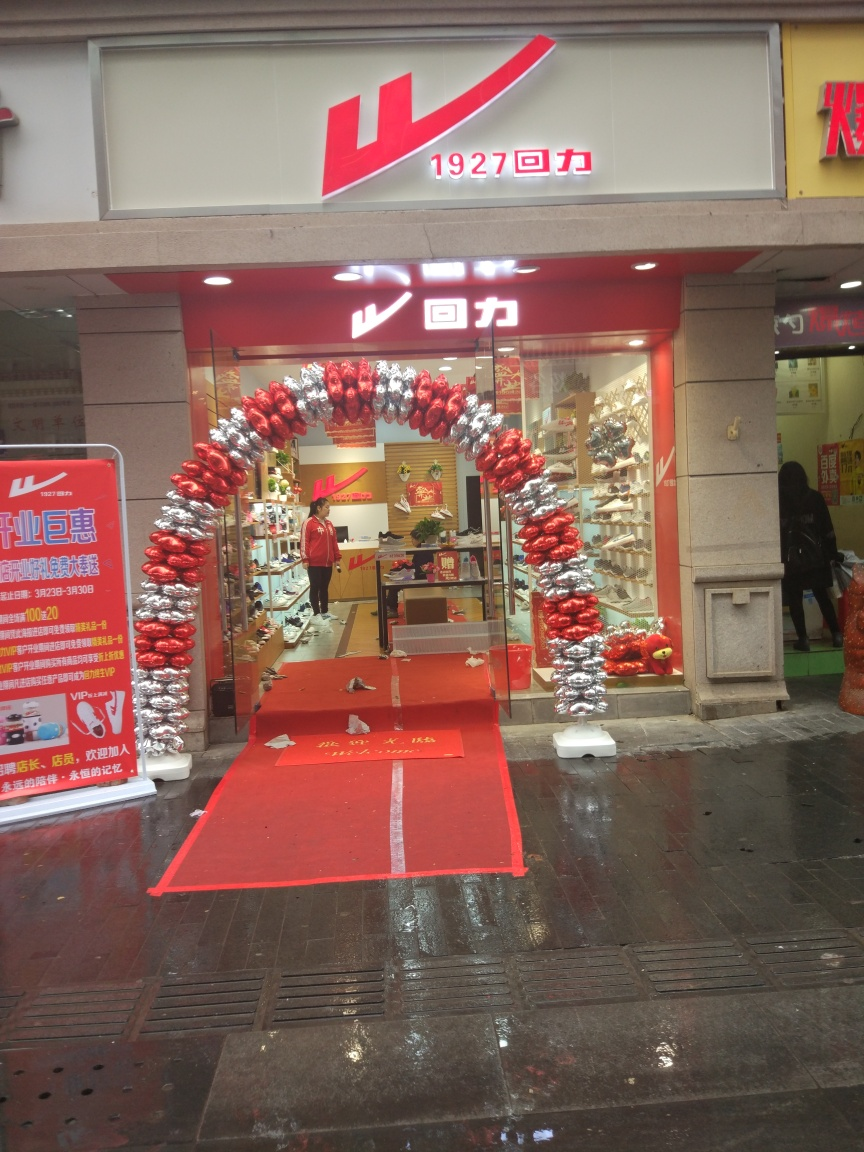Is the image quality of this photo not good?
A. No
B. Yes
Answer with the option's letter from the given choices directly.
 A. 